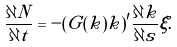<formula> <loc_0><loc_0><loc_500><loc_500>\frac { \partial N } { \partial t } = - ( G ( k ) k ) ^ { \prime } \frac { \partial k } { \partial s } \xi .</formula> 